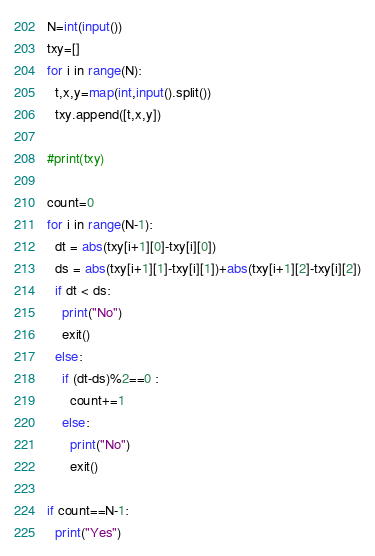Convert code to text. <code><loc_0><loc_0><loc_500><loc_500><_Python_>N=int(input())
txy=[]
for i in range(N):
  t,x,y=map(int,input().split())
  txy.append([t,x,y])
  
#print(txy)

count=0
for i in range(N-1):
  dt = abs(txy[i+1][0]-txy[i][0])
  ds = abs(txy[i+1][1]-txy[i][1])+abs(txy[i+1][2]-txy[i][2])
  if dt < ds:
    print("No")
    exit()
  else:
    if (dt-ds)%2==0 :
      count+=1
    else:
      print("No")
      exit()

if count==N-1:
  print("Yes")</code> 